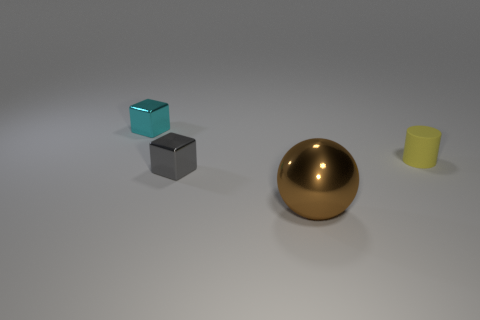Add 1 tiny brown rubber spheres. How many objects exist? 5 Subtract all cylinders. How many objects are left? 3 Add 3 green metal balls. How many green metal balls exist? 3 Subtract 1 brown balls. How many objects are left? 3 Subtract all brown cubes. Subtract all blue spheres. How many cubes are left? 2 Subtract all metallic spheres. Subtract all tiny red things. How many objects are left? 3 Add 4 gray metallic blocks. How many gray metallic blocks are left? 5 